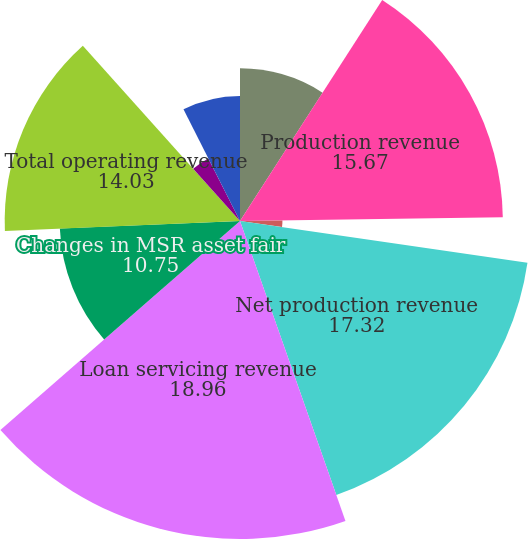Convert chart. <chart><loc_0><loc_0><loc_500><loc_500><pie_chart><fcel>(in millions)<fcel>Production revenue<fcel>Repurchase (losses)/benefits<fcel>Net production revenue<fcel>Loan servicing revenue<fcel>Changes in MSR asset fair<fcel>Total operating revenue<fcel>Other changes in MSR asset<fcel>Changes in derivative fair<nl><fcel>9.1%<fcel>15.67%<fcel>2.53%<fcel>17.32%<fcel>18.96%<fcel>10.75%<fcel>14.03%<fcel>4.18%<fcel>7.46%<nl></chart> 